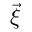<formula> <loc_0><loc_0><loc_500><loc_500>\vec { \xi }</formula> 